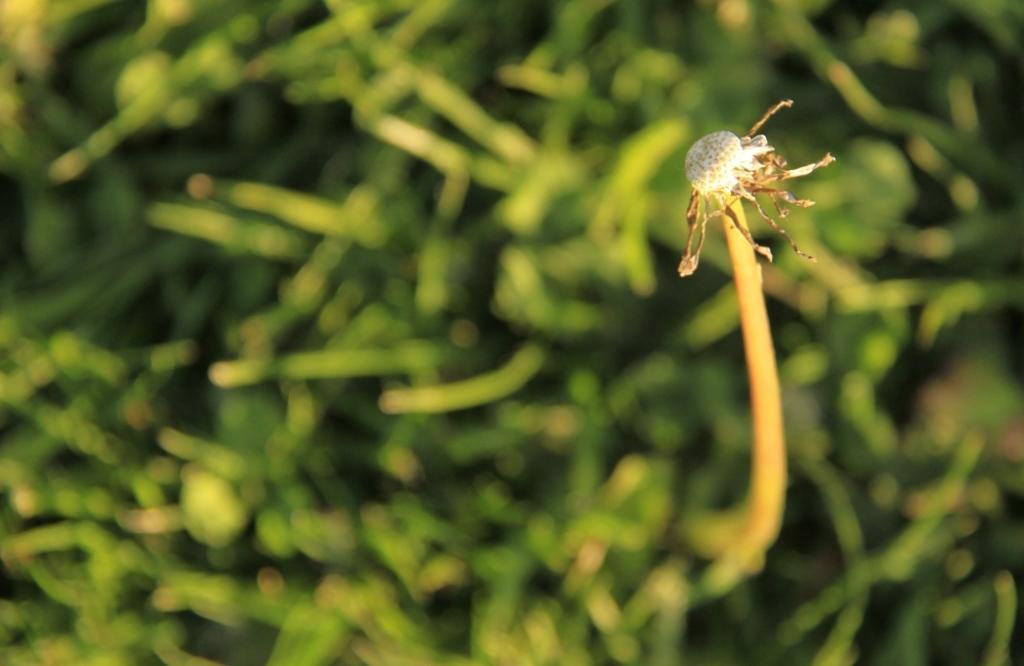Could you give a brief overview of what you see in this image? On the right we can see white color insect sitting on the grass. On the background we can see grass. 